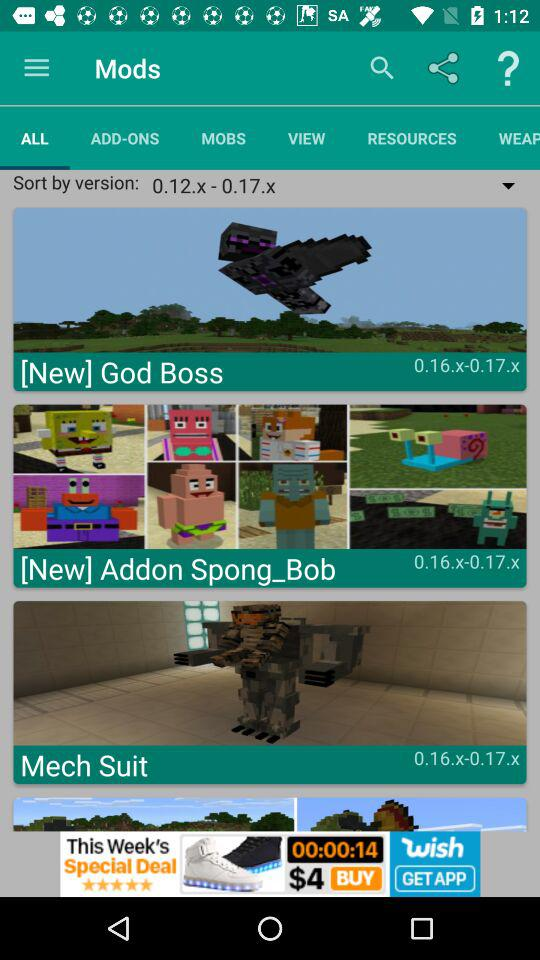How many items have a version of 0.16.x-0.17.x?
Answer the question using a single word or phrase. 3 